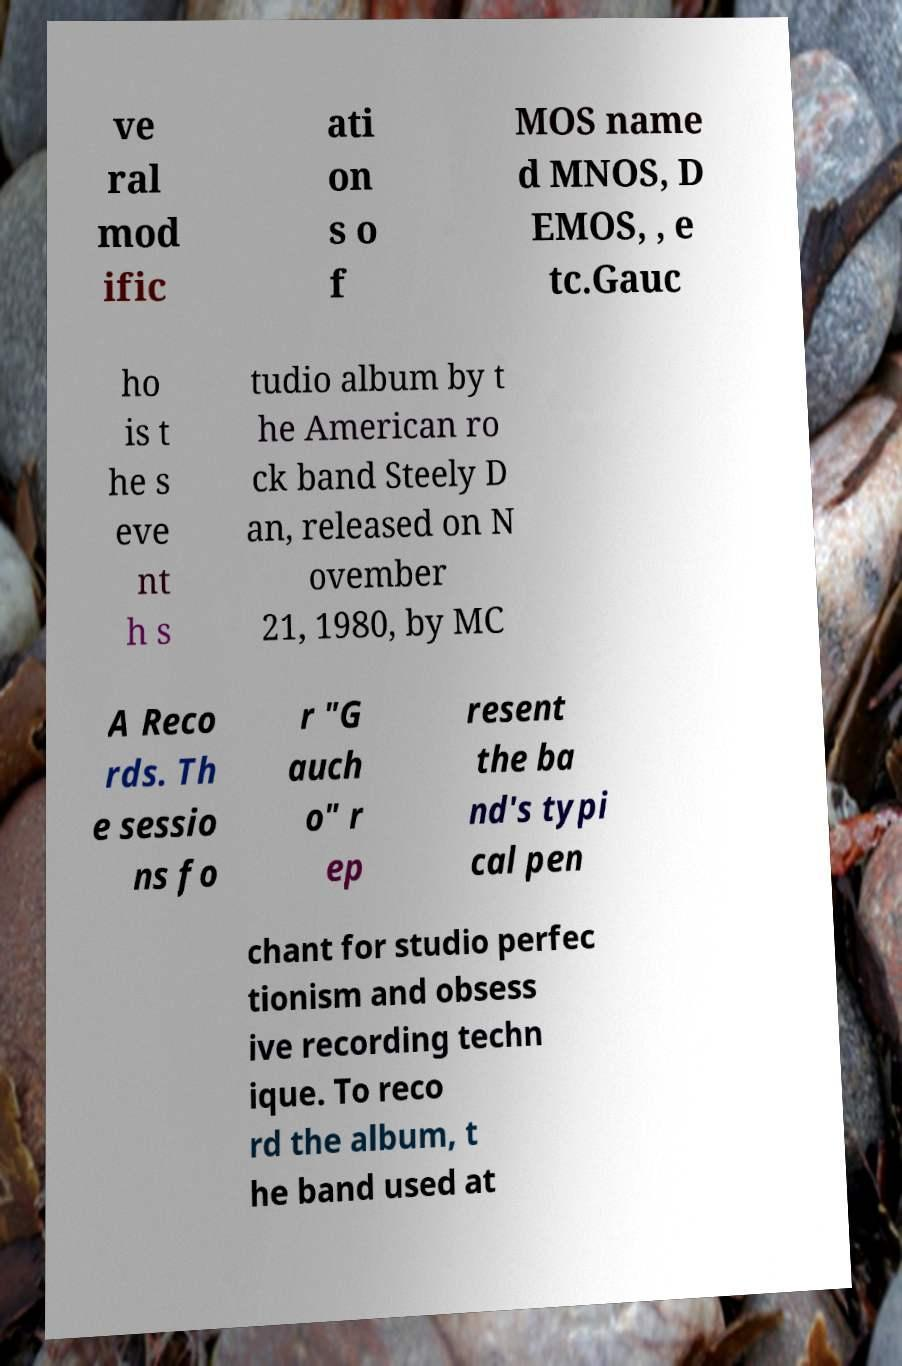Please identify and transcribe the text found in this image. ve ral mod ific ati on s o f MOS name d MNOS, D EMOS, , e tc.Gauc ho is t he s eve nt h s tudio album by t he American ro ck band Steely D an, released on N ovember 21, 1980, by MC A Reco rds. Th e sessio ns fo r "G auch o" r ep resent the ba nd's typi cal pen chant for studio perfec tionism and obsess ive recording techn ique. To reco rd the album, t he band used at 